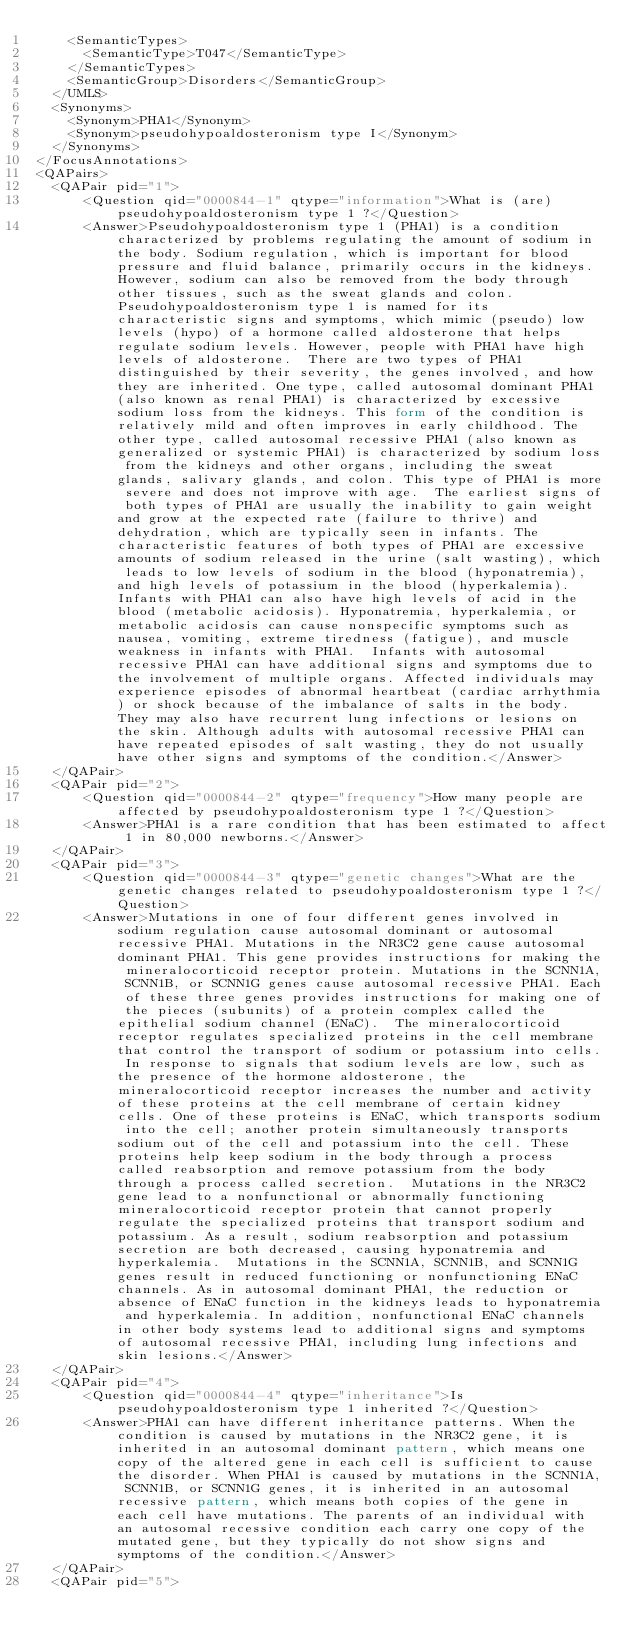Convert code to text. <code><loc_0><loc_0><loc_500><loc_500><_XML_>		<SemanticTypes>
			<SemanticType>T047</SemanticType>
		</SemanticTypes>
		<SemanticGroup>Disorders</SemanticGroup>
	</UMLS>
	<Synonyms>
		<Synonym>PHA1</Synonym>
		<Synonym>pseudohypoaldosteronism type I</Synonym>
	</Synonyms>
</FocusAnnotations>
<QAPairs>
	<QAPair pid="1">
			<Question qid="0000844-1" qtype="information">What is (are) pseudohypoaldosteronism type 1 ?</Question>
			<Answer>Pseudohypoaldosteronism type 1 (PHA1) is a condition characterized by problems regulating the amount of sodium in the body. Sodium regulation, which is important for blood pressure and fluid balance, primarily occurs in the kidneys. However, sodium can also be removed from the body through other tissues, such as the sweat glands and colon. Pseudohypoaldosteronism type 1 is named for its characteristic signs and symptoms, which mimic (pseudo) low levels (hypo) of a hormone called aldosterone that helps regulate sodium levels. However, people with PHA1 have high levels of aldosterone.  There are two types of PHA1 distinguished by their severity, the genes involved, and how they are inherited. One type, called autosomal dominant PHA1 (also known as renal PHA1) is characterized by excessive sodium loss from the kidneys. This form of the condition is relatively mild and often improves in early childhood. The other type, called autosomal recessive PHA1 (also known as generalized or systemic PHA1) is characterized by sodium loss from the kidneys and other organs, including the sweat glands, salivary glands, and colon. This type of PHA1 is more severe and does not improve with age.  The earliest signs of both types of PHA1 are usually the inability to gain weight and grow at the expected rate (failure to thrive) and dehydration, which are typically seen in infants. The characteristic features of both types of PHA1 are excessive amounts of sodium released in the urine (salt wasting), which leads to low levels of sodium in the blood (hyponatremia), and high levels of potassium in the blood (hyperkalemia). Infants with PHA1 can also have high levels of acid in the blood (metabolic acidosis). Hyponatremia, hyperkalemia, or metabolic acidosis can cause nonspecific symptoms such as nausea, vomiting, extreme tiredness (fatigue), and muscle weakness in infants with PHA1.  Infants with autosomal recessive PHA1 can have additional signs and symptoms due to the involvement of multiple organs. Affected individuals may experience episodes of abnormal heartbeat (cardiac arrhythmia) or shock because of the imbalance of salts in the body. They may also have recurrent lung infections or lesions on the skin. Although adults with autosomal recessive PHA1 can have repeated episodes of salt wasting, they do not usually have other signs and symptoms of the condition.</Answer>
	</QAPair>
	<QAPair pid="2">
			<Question qid="0000844-2" qtype="frequency">How many people are affected by pseudohypoaldosteronism type 1 ?</Question>
			<Answer>PHA1 is a rare condition that has been estimated to affect 1 in 80,000 newborns.</Answer>
	</QAPair>
	<QAPair pid="3">
			<Question qid="0000844-3" qtype="genetic changes">What are the genetic changes related to pseudohypoaldosteronism type 1 ?</Question>
			<Answer>Mutations in one of four different genes involved in sodium regulation cause autosomal dominant or autosomal recessive PHA1. Mutations in the NR3C2 gene cause autosomal dominant PHA1. This gene provides instructions for making the mineralocorticoid receptor protein. Mutations in the SCNN1A, SCNN1B, or SCNN1G genes cause autosomal recessive PHA1. Each of these three genes provides instructions for making one of the pieces (subunits) of a protein complex called the epithelial sodium channel (ENaC).  The mineralocorticoid receptor regulates specialized proteins in the cell membrane that control the transport of sodium or potassium into cells. In response to signals that sodium levels are low, such as the presence of the hormone aldosterone, the mineralocorticoid receptor increases the number and activity of these proteins at the cell membrane of certain kidney cells. One of these proteins is ENaC, which transports sodium into the cell; another protein simultaneously transports sodium out of the cell and potassium into the cell. These proteins help keep sodium in the body through a process called reabsorption and remove potassium from the body through a process called secretion.  Mutations in the NR3C2 gene lead to a nonfunctional or abnormally functioning mineralocorticoid receptor protein that cannot properly regulate the specialized proteins that transport sodium and potassium. As a result, sodium reabsorption and potassium secretion are both decreased, causing hyponatremia and hyperkalemia.  Mutations in the SCNN1A, SCNN1B, and SCNN1G genes result in reduced functioning or nonfunctioning ENaC channels. As in autosomal dominant PHA1, the reduction or absence of ENaC function in the kidneys leads to hyponatremia and hyperkalemia. In addition, nonfunctional ENaC channels in other body systems lead to additional signs and symptoms of autosomal recessive PHA1, including lung infections and skin lesions.</Answer>
	</QAPair>
	<QAPair pid="4">
			<Question qid="0000844-4" qtype="inheritance">Is pseudohypoaldosteronism type 1 inherited ?</Question>
			<Answer>PHA1 can have different inheritance patterns. When the condition is caused by mutations in the NR3C2 gene, it is inherited in an autosomal dominant pattern, which means one copy of the altered gene in each cell is sufficient to cause the disorder. When PHA1 is caused by mutations in the SCNN1A, SCNN1B, or SCNN1G genes, it is inherited in an autosomal recessive pattern, which means both copies of the gene in each cell have mutations. The parents of an individual with an autosomal recessive condition each carry one copy of the mutated gene, but they typically do not show signs and symptoms of the condition.</Answer>
	</QAPair>
	<QAPair pid="5"></code> 